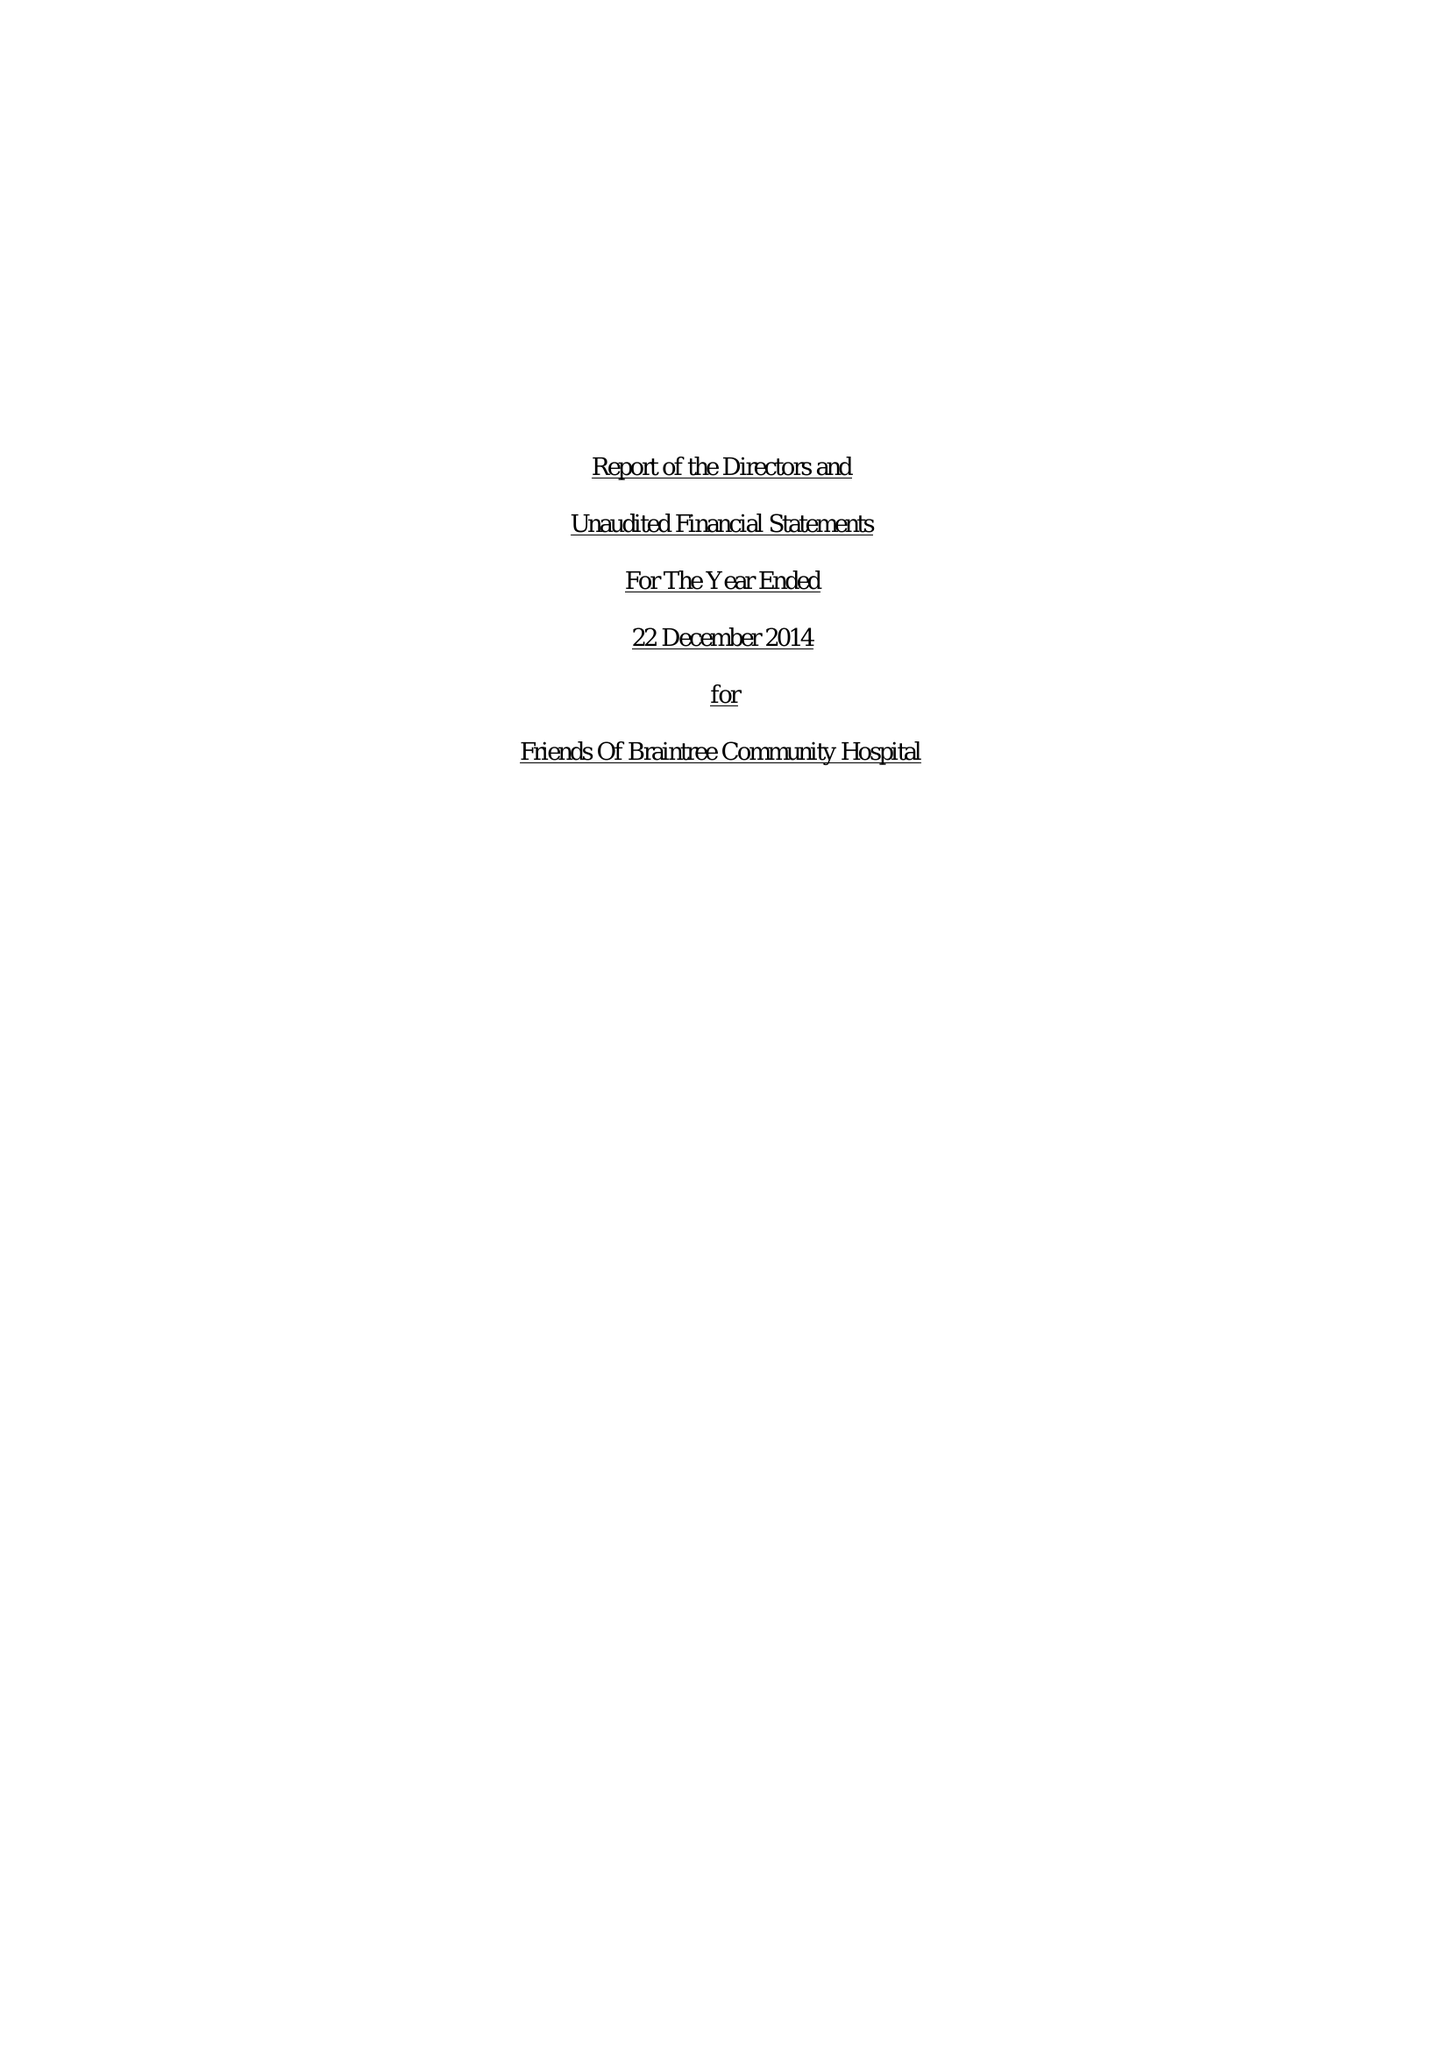What is the value for the spending_annually_in_british_pounds?
Answer the question using a single word or phrase. 23774.00 